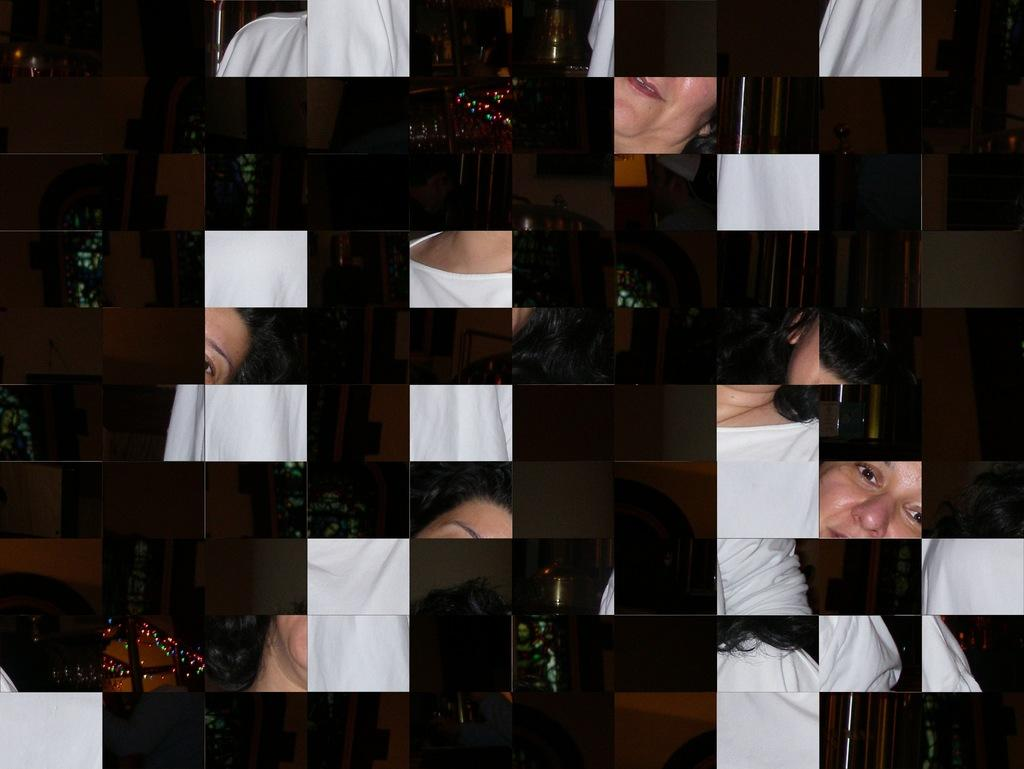What is the main subject in the image? There is a puzzle in the image. How is the puzzle depicted in the image? The puzzle is not arranged in the image. What is the name of the wall that the puzzle is leaning against in the image? There is no wall present in the image, and therefore no such leaning can be observed. What type of cracker is visible in the image? There are no crackers present in the image. 